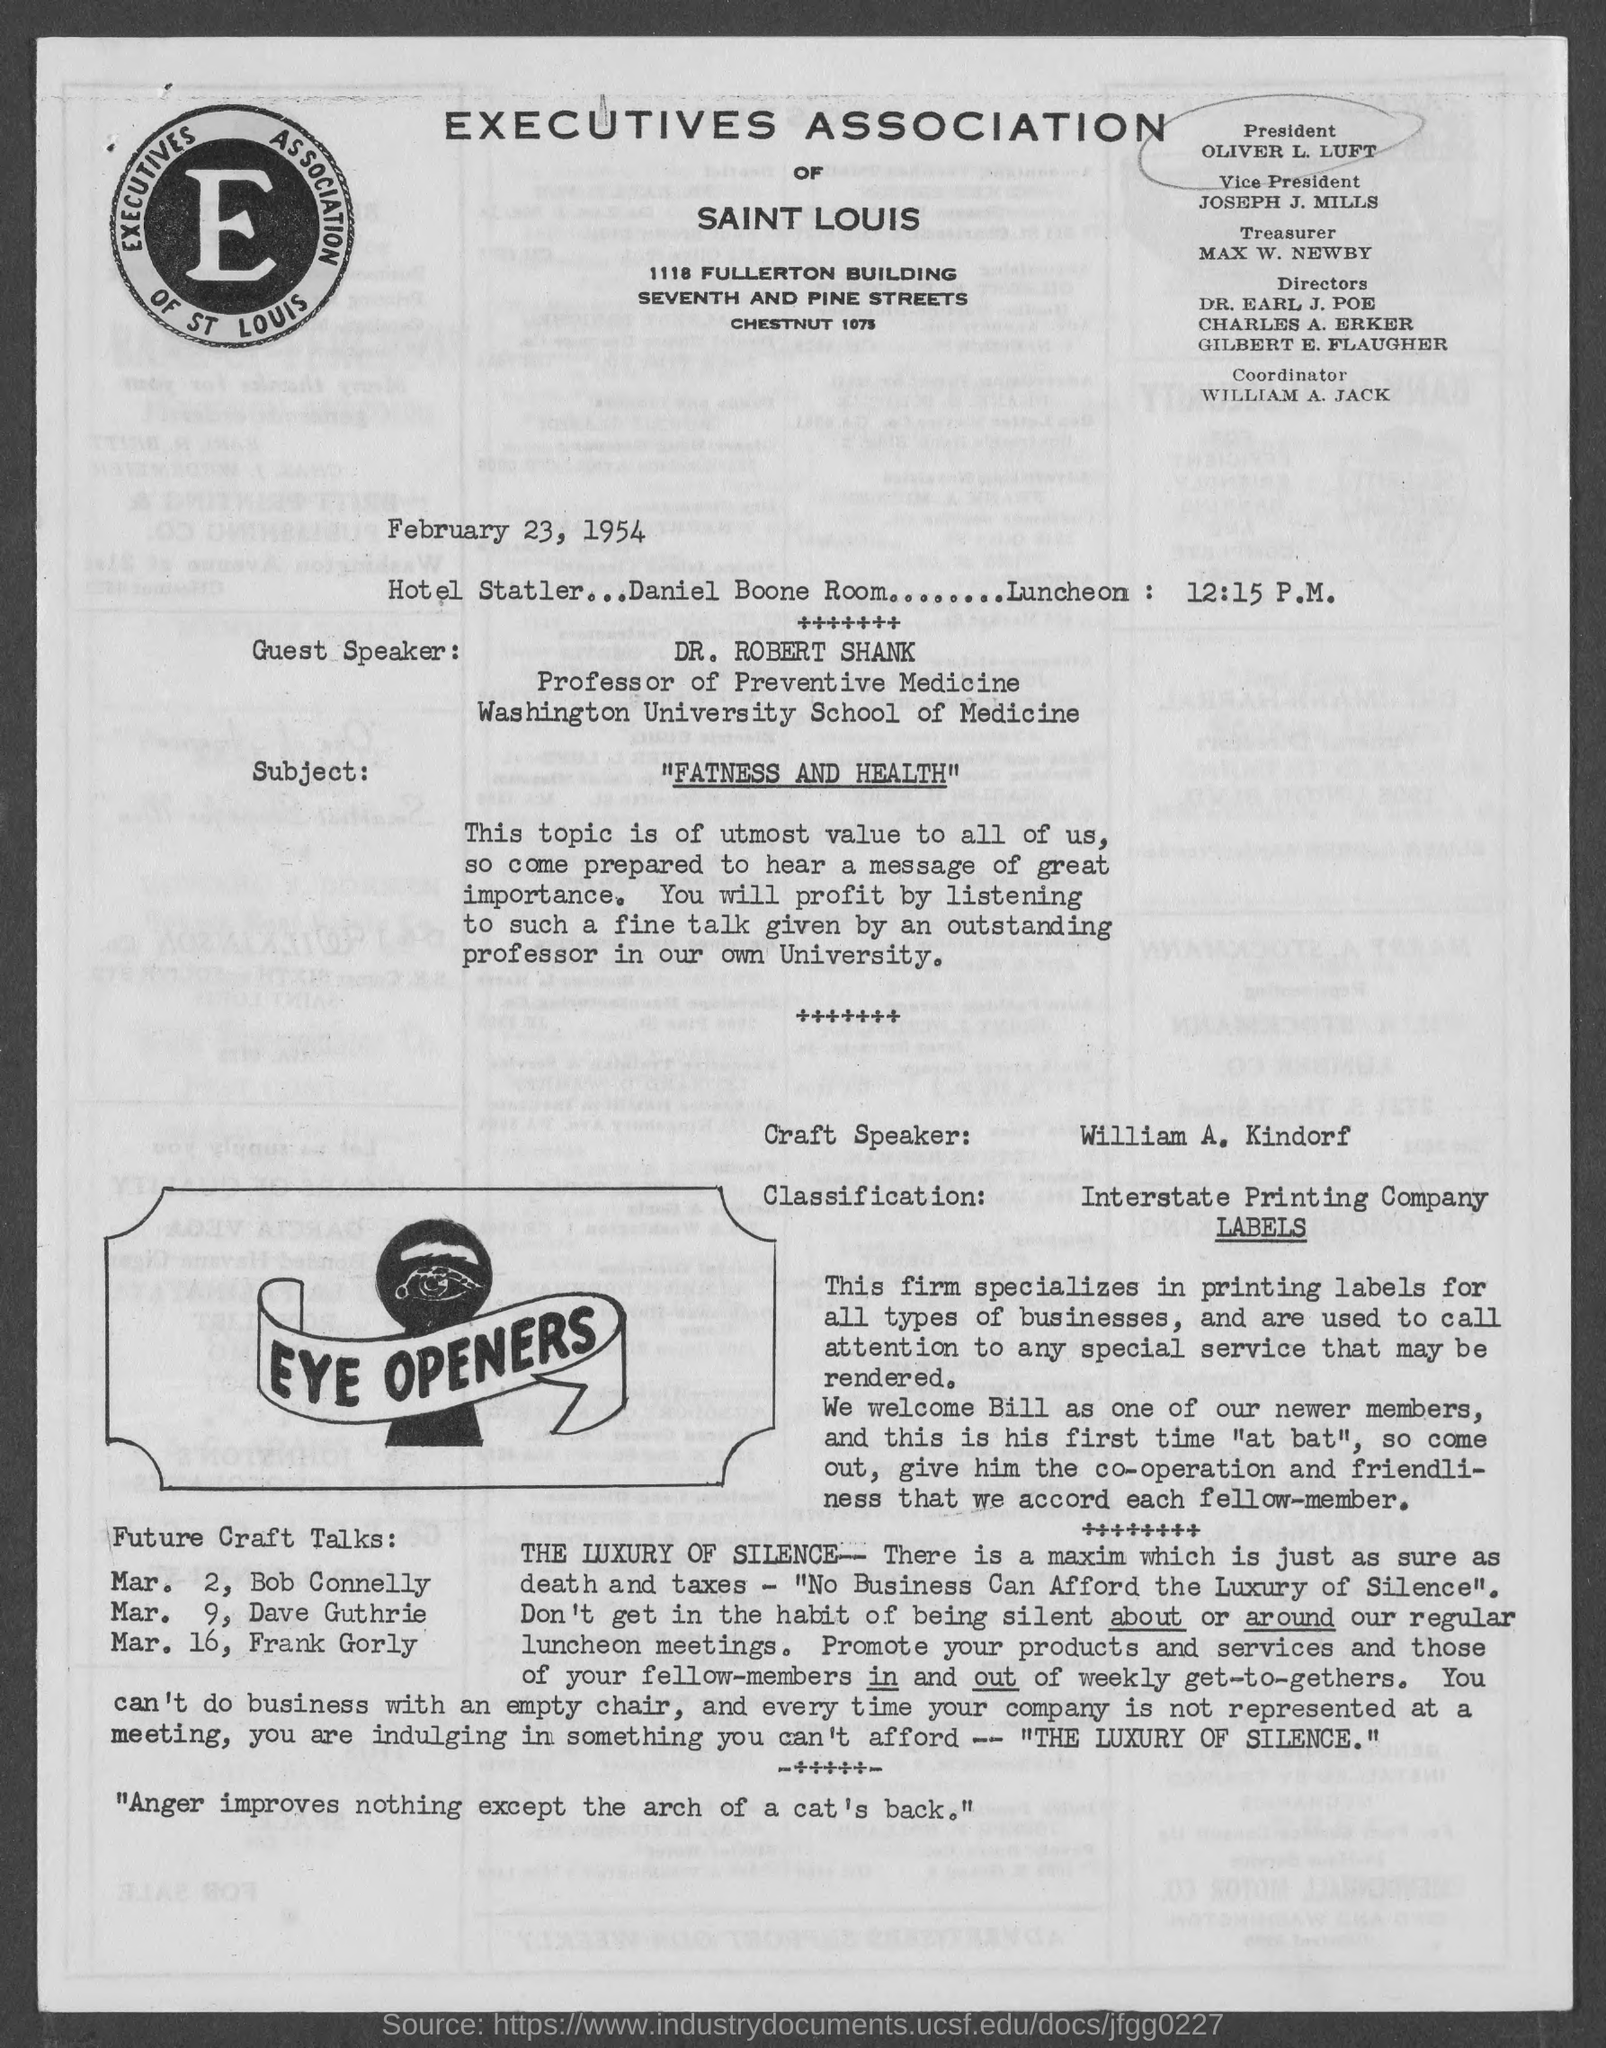Who is the president?
Ensure brevity in your answer.  Oliver L. Luft. Who is the  vice president?
Ensure brevity in your answer.  JOSEPH J. MILLS. Who is the treasurer?
Keep it short and to the point. MAX W. NEWBY. Who is the coordinator?
Ensure brevity in your answer.  William A. Jack. When is the document dated?
Keep it short and to the point. February 23, 1954. What is the Subject?
Provide a succinct answer. Fatness and health. Who is the Craft Speaker?
Provide a short and direct response. William A. Kindorf. What is the classification given?
Your answer should be very brief. Interstate Printing Company. 